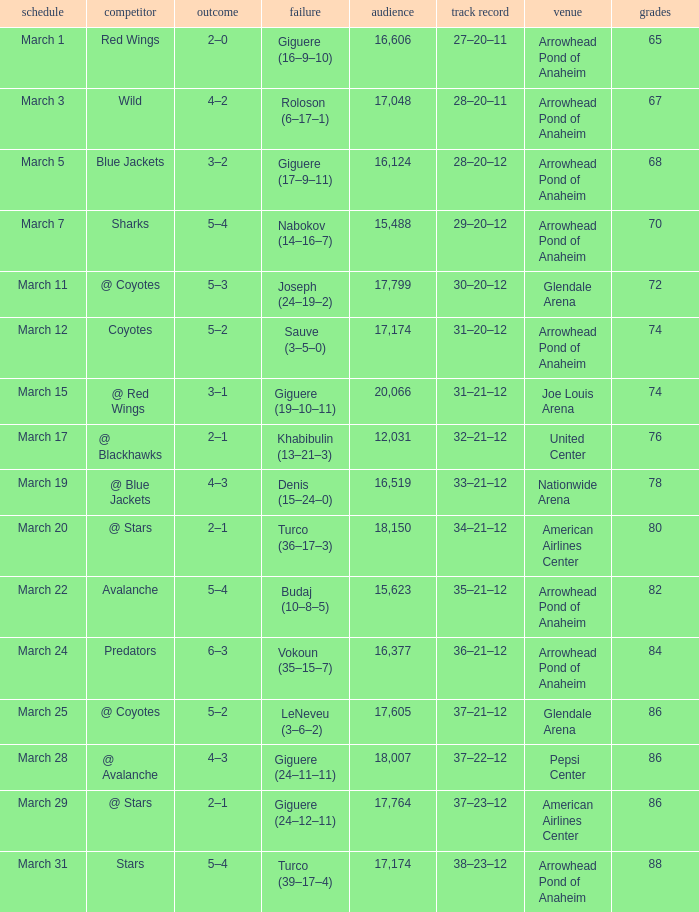What is the Loss of the game at Nationwide Arena with a Score of 4–3? Denis (15–24–0). 